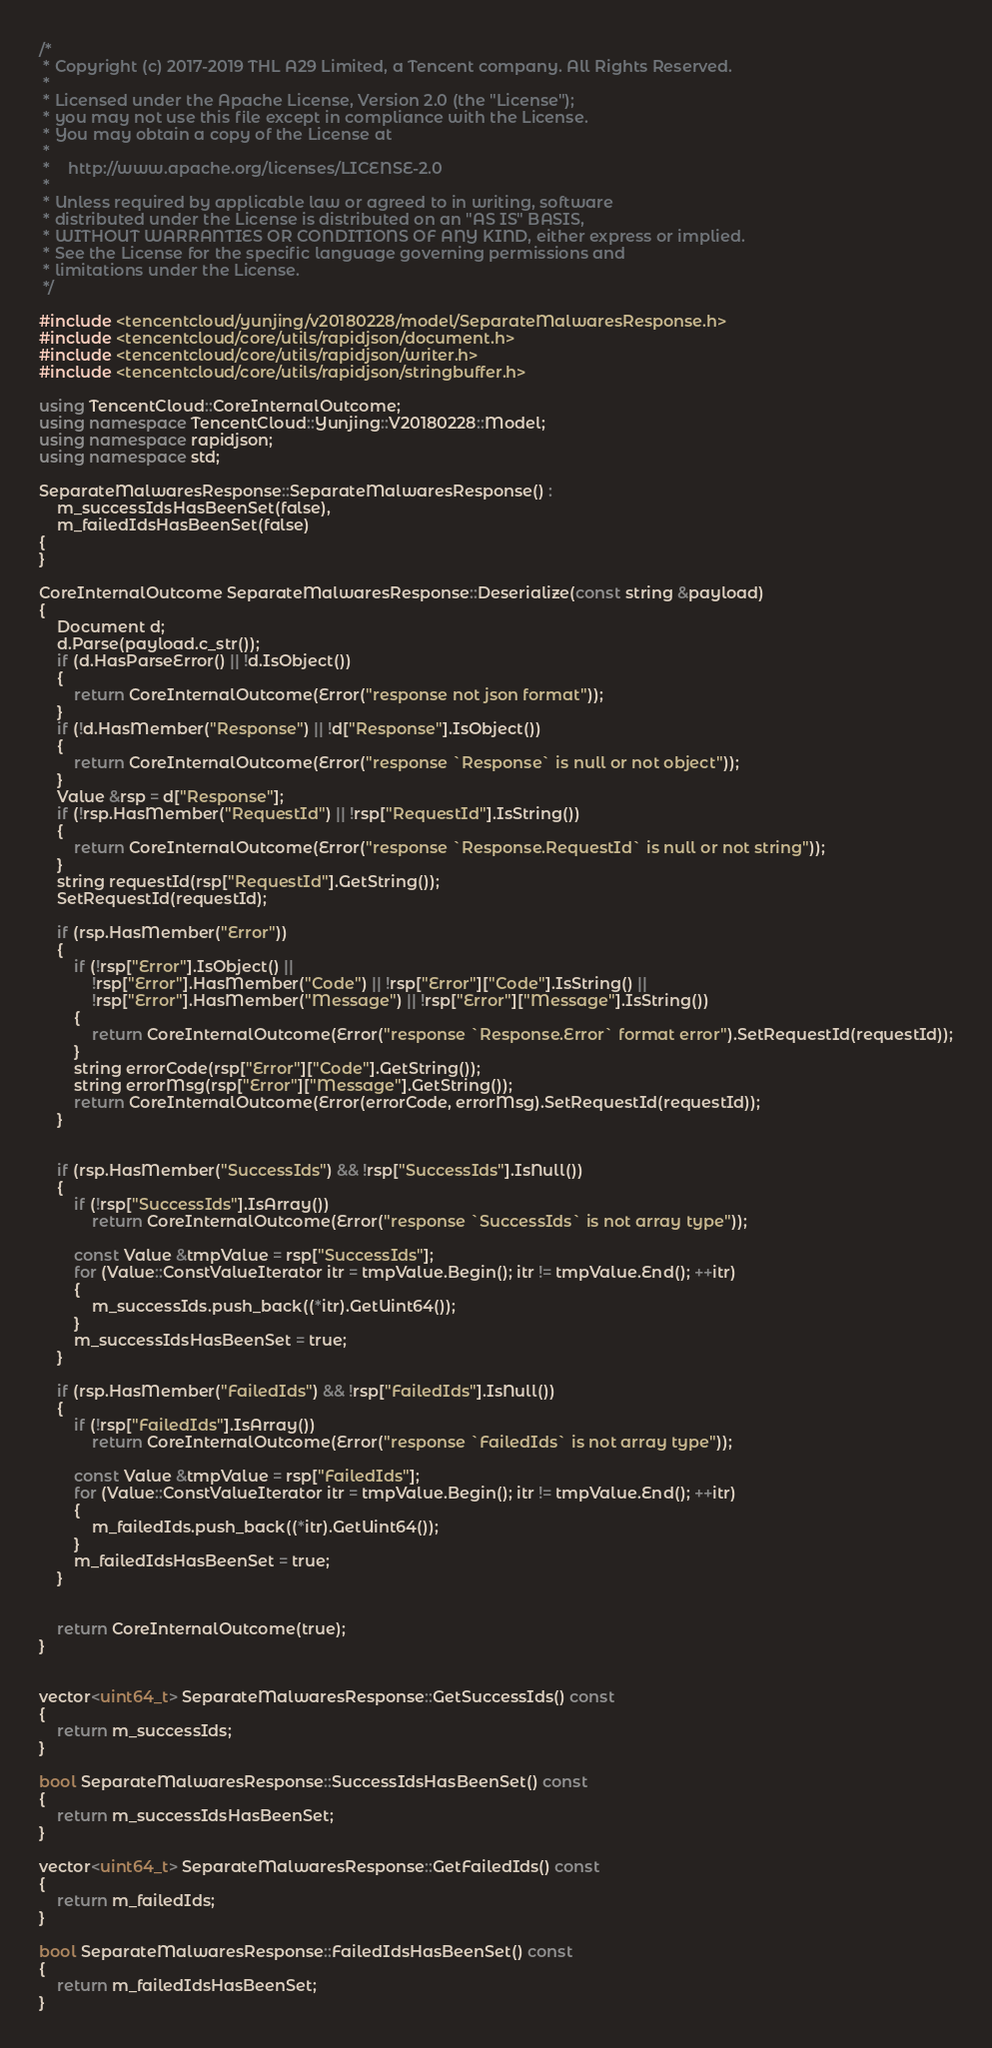Convert code to text. <code><loc_0><loc_0><loc_500><loc_500><_C++_>/*
 * Copyright (c) 2017-2019 THL A29 Limited, a Tencent company. All Rights Reserved.
 *
 * Licensed under the Apache License, Version 2.0 (the "License");
 * you may not use this file except in compliance with the License.
 * You may obtain a copy of the License at
 *
 *    http://www.apache.org/licenses/LICENSE-2.0
 *
 * Unless required by applicable law or agreed to in writing, software
 * distributed under the License is distributed on an "AS IS" BASIS,
 * WITHOUT WARRANTIES OR CONDITIONS OF ANY KIND, either express or implied.
 * See the License for the specific language governing permissions and
 * limitations under the License.
 */

#include <tencentcloud/yunjing/v20180228/model/SeparateMalwaresResponse.h>
#include <tencentcloud/core/utils/rapidjson/document.h>
#include <tencentcloud/core/utils/rapidjson/writer.h>
#include <tencentcloud/core/utils/rapidjson/stringbuffer.h>

using TencentCloud::CoreInternalOutcome;
using namespace TencentCloud::Yunjing::V20180228::Model;
using namespace rapidjson;
using namespace std;

SeparateMalwaresResponse::SeparateMalwaresResponse() :
    m_successIdsHasBeenSet(false),
    m_failedIdsHasBeenSet(false)
{
}

CoreInternalOutcome SeparateMalwaresResponse::Deserialize(const string &payload)
{
    Document d;
    d.Parse(payload.c_str());
    if (d.HasParseError() || !d.IsObject())
    {
        return CoreInternalOutcome(Error("response not json format"));
    }
    if (!d.HasMember("Response") || !d["Response"].IsObject())
    {
        return CoreInternalOutcome(Error("response `Response` is null or not object"));
    }
    Value &rsp = d["Response"];
    if (!rsp.HasMember("RequestId") || !rsp["RequestId"].IsString())
    {
        return CoreInternalOutcome(Error("response `Response.RequestId` is null or not string"));
    }
    string requestId(rsp["RequestId"].GetString());
    SetRequestId(requestId);

    if (rsp.HasMember("Error"))
    {
        if (!rsp["Error"].IsObject() ||
            !rsp["Error"].HasMember("Code") || !rsp["Error"]["Code"].IsString() ||
            !rsp["Error"].HasMember("Message") || !rsp["Error"]["Message"].IsString())
        {
            return CoreInternalOutcome(Error("response `Response.Error` format error").SetRequestId(requestId));
        }
        string errorCode(rsp["Error"]["Code"].GetString());
        string errorMsg(rsp["Error"]["Message"].GetString());
        return CoreInternalOutcome(Error(errorCode, errorMsg).SetRequestId(requestId));
    }


    if (rsp.HasMember("SuccessIds") && !rsp["SuccessIds"].IsNull())
    {
        if (!rsp["SuccessIds"].IsArray())
            return CoreInternalOutcome(Error("response `SuccessIds` is not array type"));

        const Value &tmpValue = rsp["SuccessIds"];
        for (Value::ConstValueIterator itr = tmpValue.Begin(); itr != tmpValue.End(); ++itr)
        {
            m_successIds.push_back((*itr).GetUint64());
        }
        m_successIdsHasBeenSet = true;
    }

    if (rsp.HasMember("FailedIds") && !rsp["FailedIds"].IsNull())
    {
        if (!rsp["FailedIds"].IsArray())
            return CoreInternalOutcome(Error("response `FailedIds` is not array type"));

        const Value &tmpValue = rsp["FailedIds"];
        for (Value::ConstValueIterator itr = tmpValue.Begin(); itr != tmpValue.End(); ++itr)
        {
            m_failedIds.push_back((*itr).GetUint64());
        }
        m_failedIdsHasBeenSet = true;
    }


    return CoreInternalOutcome(true);
}


vector<uint64_t> SeparateMalwaresResponse::GetSuccessIds() const
{
    return m_successIds;
}

bool SeparateMalwaresResponse::SuccessIdsHasBeenSet() const
{
    return m_successIdsHasBeenSet;
}

vector<uint64_t> SeparateMalwaresResponse::GetFailedIds() const
{
    return m_failedIds;
}

bool SeparateMalwaresResponse::FailedIdsHasBeenSet() const
{
    return m_failedIdsHasBeenSet;
}


</code> 